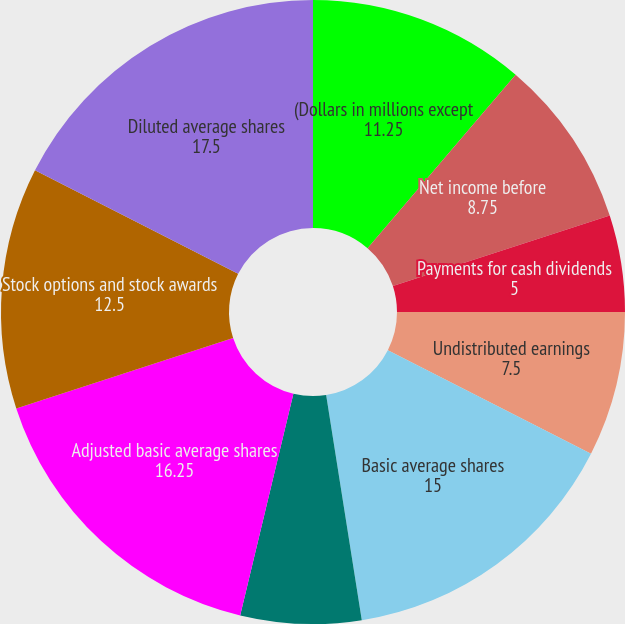Convert chart to OTSL. <chart><loc_0><loc_0><loc_500><loc_500><pie_chart><fcel>(Dollars in millions except<fcel>Net income before<fcel>Payments for cash dividends<fcel>Undistributed earnings<fcel>Basic average shares<fcel>Average participating<fcel>Adjusted basic average shares<fcel>Stock options and stock awards<fcel>Diluted average shares<nl><fcel>11.25%<fcel>8.75%<fcel>5.0%<fcel>7.5%<fcel>15.0%<fcel>6.25%<fcel>16.25%<fcel>12.5%<fcel>17.5%<nl></chart> 